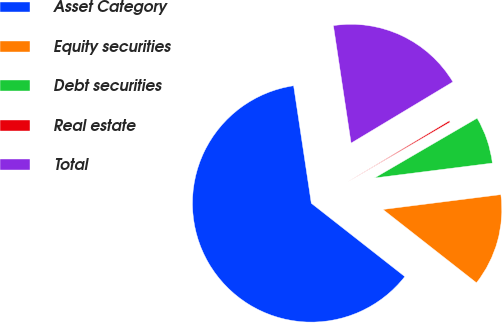Convert chart to OTSL. <chart><loc_0><loc_0><loc_500><loc_500><pie_chart><fcel>Asset Category<fcel>Equity securities<fcel>Debt securities<fcel>Real estate<fcel>Total<nl><fcel>62.04%<fcel>12.58%<fcel>6.4%<fcel>0.22%<fcel>18.76%<nl></chart> 